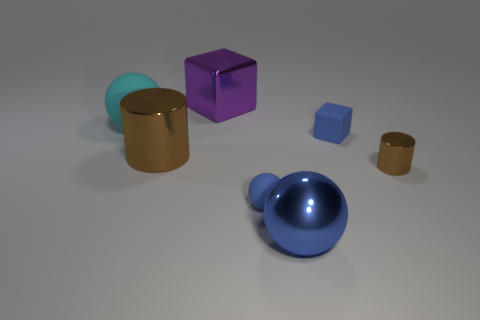There is a small object in front of the brown cylinder that is on the right side of the big brown metallic cylinder; what is it made of?
Keep it short and to the point. Rubber. Does the large purple thing have the same shape as the small metallic thing?
Make the answer very short. No. There is a metal cylinder that is the same size as the blue rubber block; what is its color?
Offer a very short reply. Brown. Are there any small metallic cubes that have the same color as the large shiny sphere?
Provide a succinct answer. No. Is there a big metal ball?
Make the answer very short. Yes. Does the large object that is in front of the tiny rubber sphere have the same material as the purple block?
Offer a terse response. Yes. The other sphere that is the same color as the tiny matte sphere is what size?
Your answer should be very brief. Large. What number of blue balls are the same size as the purple thing?
Keep it short and to the point. 1. Are there an equal number of big cyan spheres on the right side of the large metal block and blue rubber cubes?
Your answer should be very brief. No. What number of things are left of the blue shiny object and in front of the small brown cylinder?
Ensure brevity in your answer.  1. 